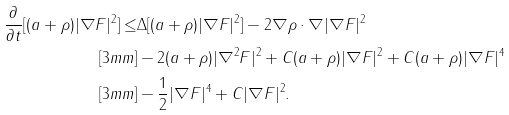<formula> <loc_0><loc_0><loc_500><loc_500>\frac { \partial } { \partial t } [ ( a + \rho ) | \nabla F | ^ { 2 } ] \leq & \Delta [ ( a + \rho ) | \nabla F | ^ { 2 } ] - 2 \nabla \rho \cdot \nabla | \nabla F | ^ { 2 } \\ [ 3 m m ] & - 2 ( a + \rho ) | \nabla ^ { 2 } F | ^ { 2 } + C ( a + \rho ) | \nabla F | ^ { 2 } + C ( a + \rho ) | \nabla F | ^ { 4 } \\ [ 3 m m ] & - \frac { 1 } { 2 } | \nabla F | ^ { 4 } + C | \nabla F | ^ { 2 } .</formula> 